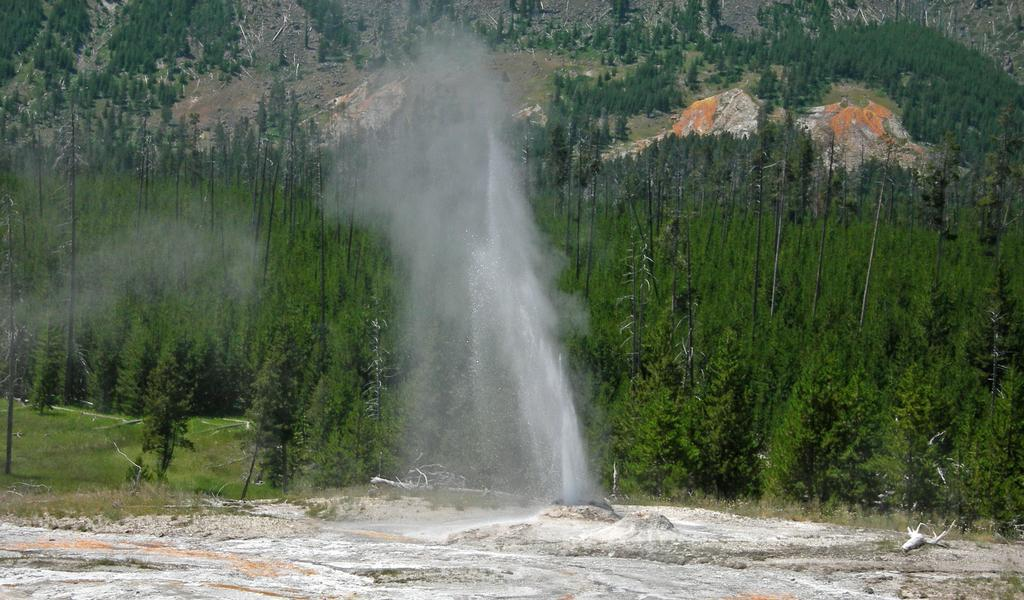What is happening in the image? There is a water explosion in the image. What can be seen in the background of the image? There are trees in the background of the image. Can you see a wren perched on one of the trees in the image? There is no wren present in the image; only a water explosion and trees are visible. 